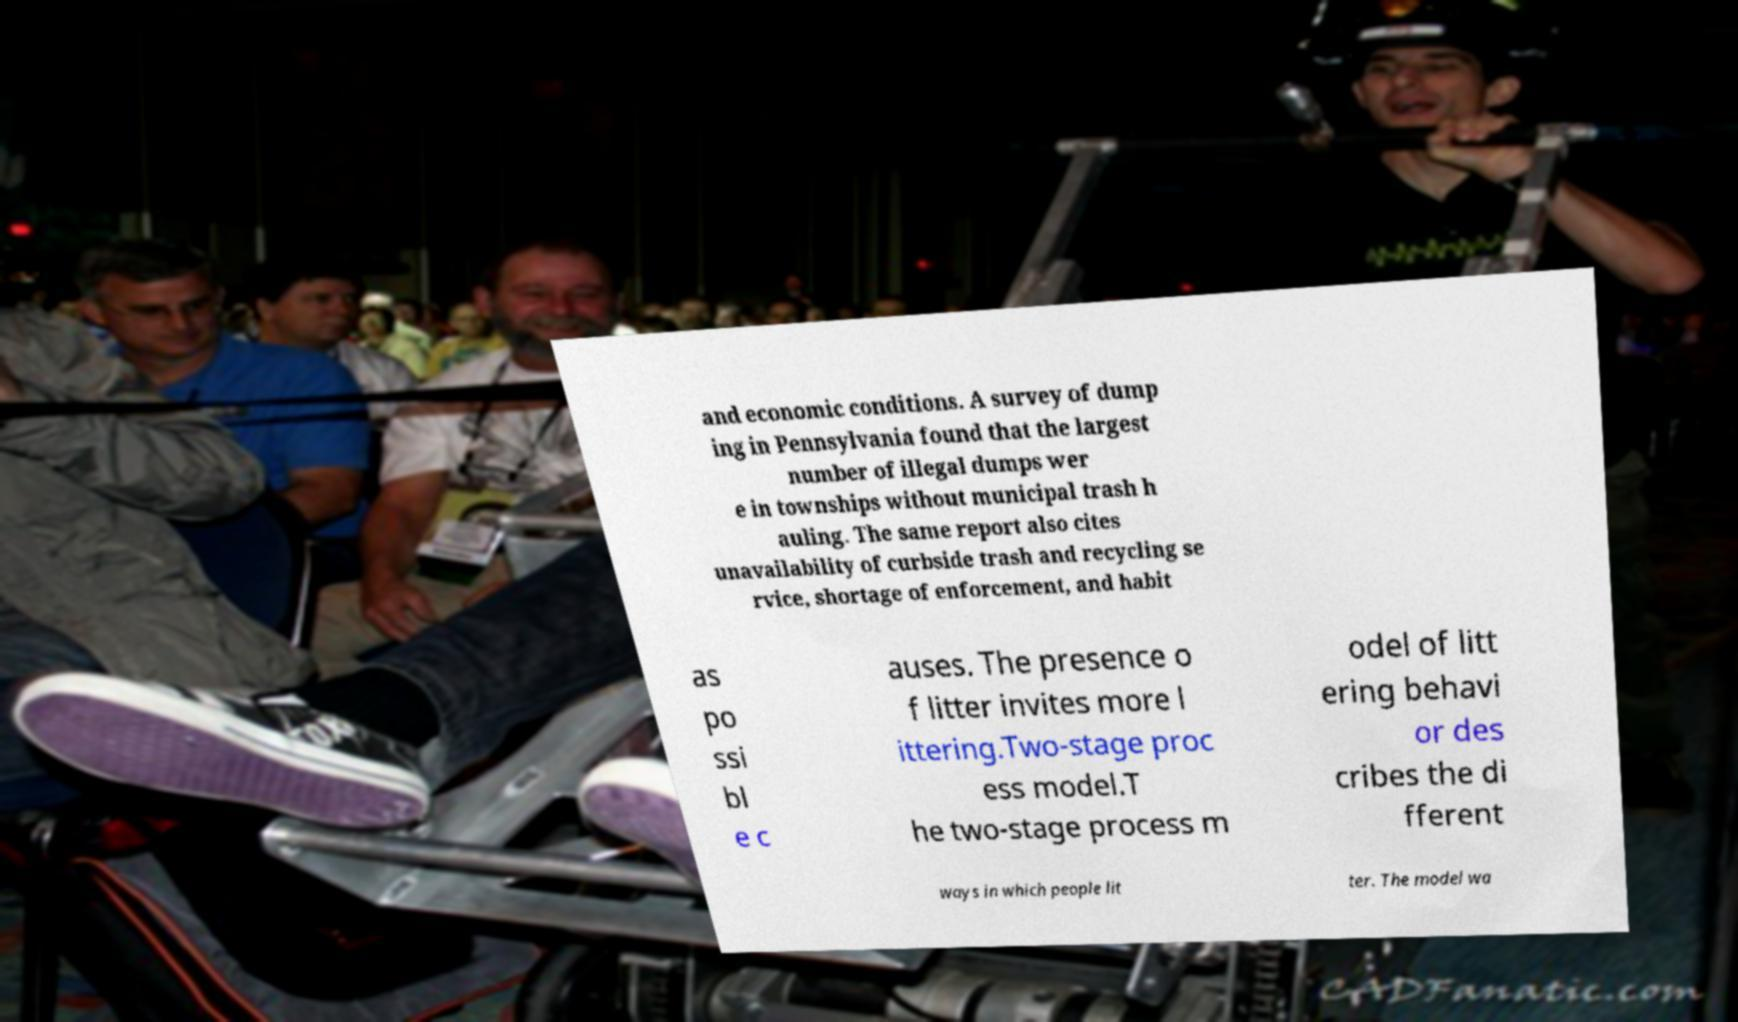Please read and relay the text visible in this image. What does it say? and economic conditions. A survey of dump ing in Pennsylvania found that the largest number of illegal dumps wer e in townships without municipal trash h auling. The same report also cites unavailability of curbside trash and recycling se rvice, shortage of enforcement, and habit as po ssi bl e c auses. The presence o f litter invites more l ittering.Two-stage proc ess model.T he two-stage process m odel of litt ering behavi or des cribes the di fferent ways in which people lit ter. The model wa 